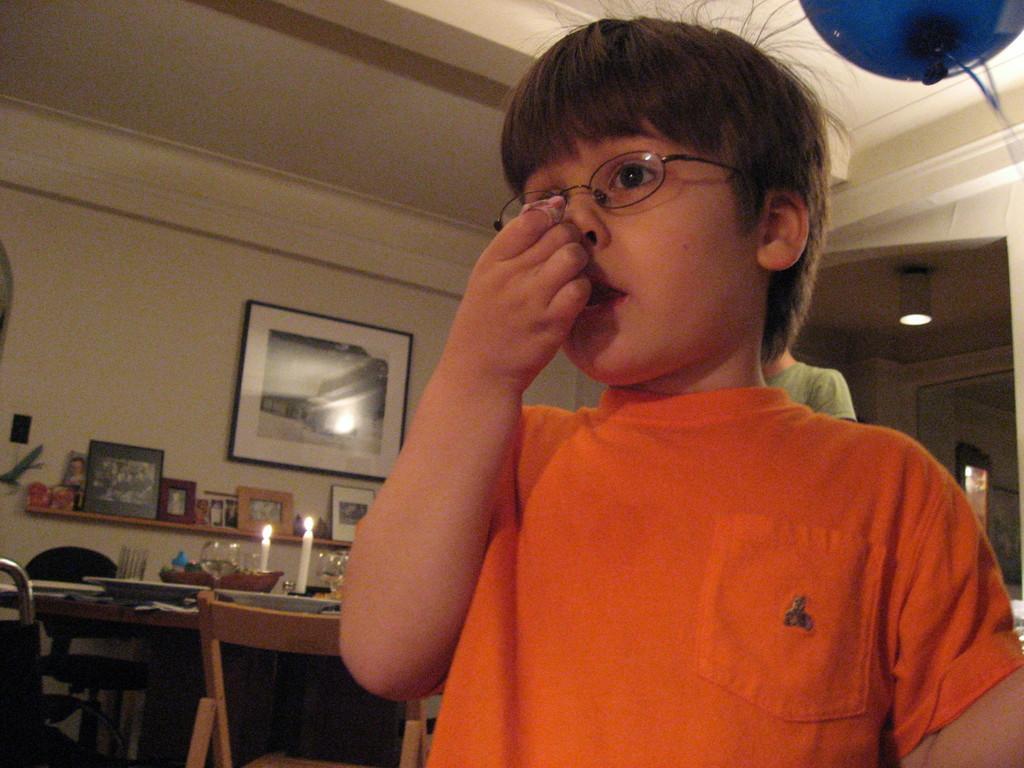In one or two sentences, can you explain what this image depicts? This is a picture inside view of an house and a person wearing a orange color shirt And his wearing a spectacles on the right side he is standing ,back side of him there is a light visible , on the left side there is a table , on the table there is a candles and in front of the table there is a chair visible And left corner there a wall ,on the wall a photo frames attached to the wall. 